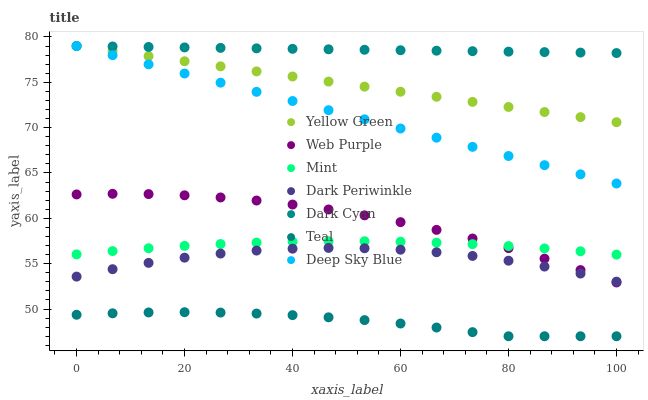Does Teal have the minimum area under the curve?
Answer yes or no. Yes. Does Dark Cyan have the maximum area under the curve?
Answer yes or no. Yes. Does Web Purple have the minimum area under the curve?
Answer yes or no. No. Does Web Purple have the maximum area under the curve?
Answer yes or no. No. Is Deep Sky Blue the smoothest?
Answer yes or no. Yes. Is Dark Periwinkle the roughest?
Answer yes or no. Yes. Is Web Purple the smoothest?
Answer yes or no. No. Is Web Purple the roughest?
Answer yes or no. No. Does Teal have the lowest value?
Answer yes or no. Yes. Does Web Purple have the lowest value?
Answer yes or no. No. Does Deep Sky Blue have the highest value?
Answer yes or no. Yes. Does Web Purple have the highest value?
Answer yes or no. No. Is Mint less than Deep Sky Blue?
Answer yes or no. Yes. Is Yellow Green greater than Dark Periwinkle?
Answer yes or no. Yes. Does Mint intersect Web Purple?
Answer yes or no. Yes. Is Mint less than Web Purple?
Answer yes or no. No. Is Mint greater than Web Purple?
Answer yes or no. No. Does Mint intersect Deep Sky Blue?
Answer yes or no. No. 